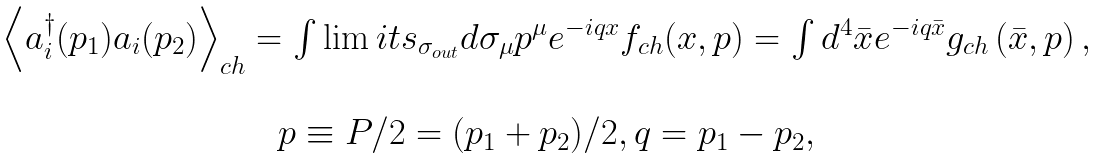Convert formula to latex. <formula><loc_0><loc_0><loc_500><loc_500>\begin{array} { c } \left \langle a _ { i } ^ { \dagger } ( { p } _ { 1 } ) a _ { i } ( { p } _ { 2 } ) \right \rangle _ { c h } = \int \lim i t s _ { \sigma _ { o u t } } d \sigma _ { \mu } p ^ { \mu } e ^ { - i q x } f _ { c h } ( x , p ) = \int d ^ { 4 } \bar { x } e ^ { - i q \bar { x } } g _ { c h } \left ( \bar { x } , p \right ) , \\ \\ p \equiv P / 2 = ( p _ { 1 } + p _ { 2 } ) / 2 , q = p _ { 1 } - p _ { 2 } , \end{array}</formula> 